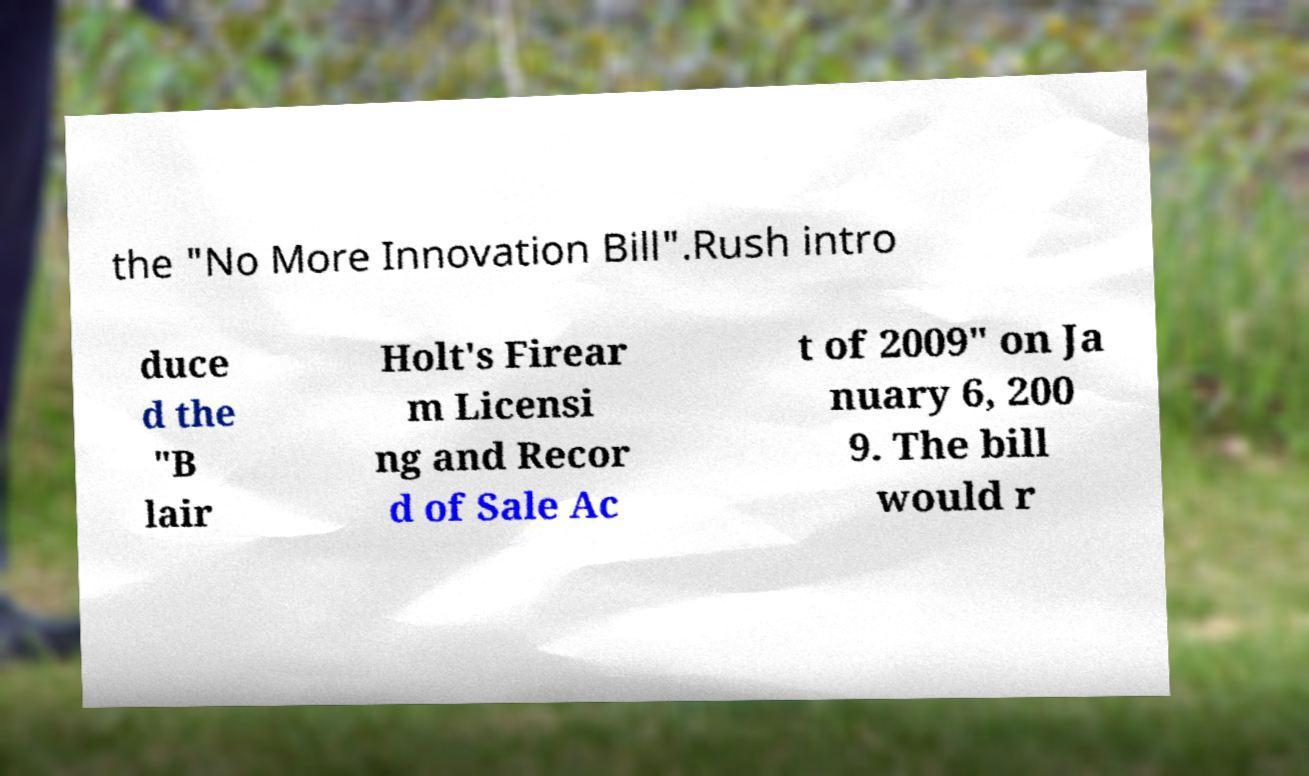Could you extract and type out the text from this image? the "No More Innovation Bill".Rush intro duce d the "B lair Holt's Firear m Licensi ng and Recor d of Sale Ac t of 2009" on Ja nuary 6, 200 9. The bill would r 